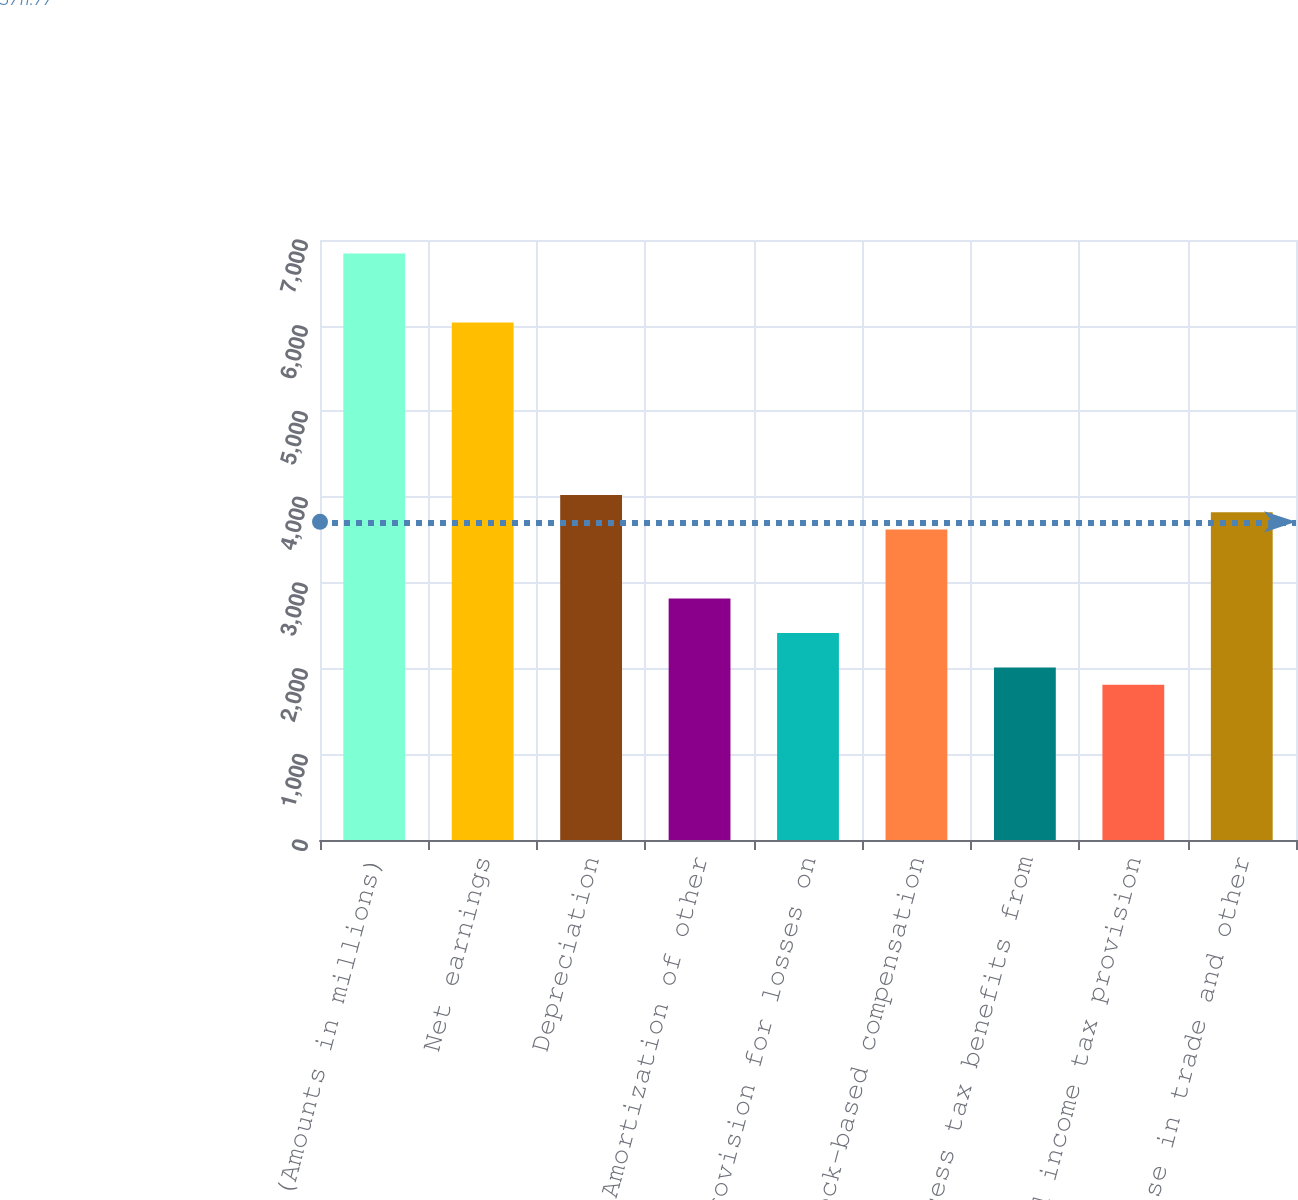<chart> <loc_0><loc_0><loc_500><loc_500><bar_chart><fcel>(Amounts in millions)<fcel>Net earnings<fcel>Depreciation<fcel>Amortization of other<fcel>Provision for losses on<fcel>Stock-based compensation<fcel>Excess tax benefits from<fcel>Deferred income tax provision<fcel>Increase in trade and other<nl><fcel>6841.08<fcel>6036.4<fcel>4024.7<fcel>2817.68<fcel>2415.34<fcel>3622.36<fcel>2013<fcel>1811.83<fcel>3823.53<nl></chart> 